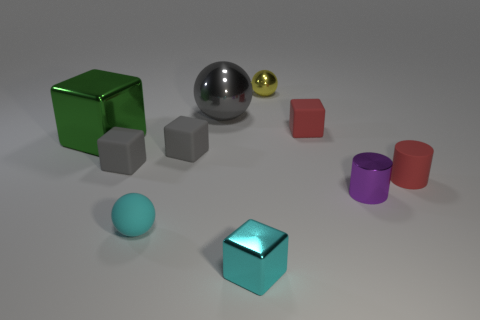Subtract all matte cubes. How many cubes are left? 2 Subtract all red cubes. How many cubes are left? 4 Subtract 3 cubes. How many cubes are left? 2 Add 7 shiny spheres. How many shiny spheres exist? 9 Subtract 0 red balls. How many objects are left? 10 Subtract all balls. How many objects are left? 7 Subtract all green balls. Subtract all purple cylinders. How many balls are left? 3 Subtract all brown balls. How many green blocks are left? 1 Subtract all red metal balls. Subtract all big green metallic things. How many objects are left? 9 Add 1 purple cylinders. How many purple cylinders are left? 2 